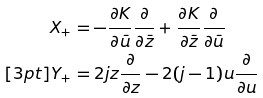<formula> <loc_0><loc_0><loc_500><loc_500>X _ { + } & = - \frac { \partial K } { \partial \bar { u } } \frac { \partial } { \partial \bar { z } } + \frac { \partial K } { \partial \bar { z } } \frac { \partial } { \partial \bar { u } } \\ [ 3 p t ] Y _ { + } & = 2 j z \frac { \partial } { \partial z } - 2 ( j - 1 ) u \frac { \partial } { \partial u }</formula> 